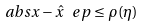<formula> <loc_0><loc_0><loc_500><loc_500>\ a b s { x - \hat { x } ^ { \ } e p } \leq \rho ( \eta )</formula> 